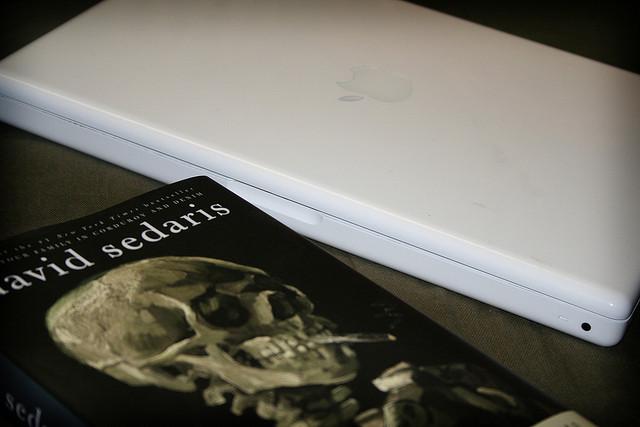What is the title of this book?
Be succinct. David sedaris. What brand is the computer?
Be succinct. Apple. Where is the skeleton?
Give a very brief answer. Book. What is the author?
Concise answer only. David sedaris. What is unique about this copy?
Be succinct. Nothing. 